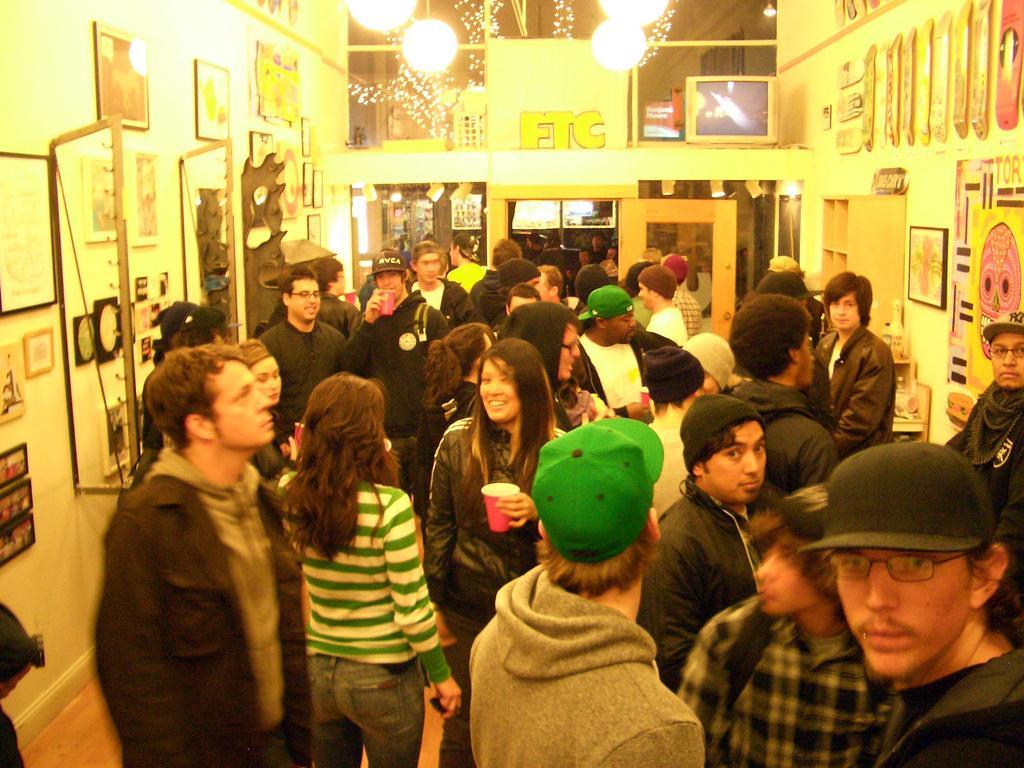How would you summarize this image in a sentence or two? In this picture we observe many people are there in the room and in the background we observe photographs fitted to the wall and there are lights attached to the roof. 